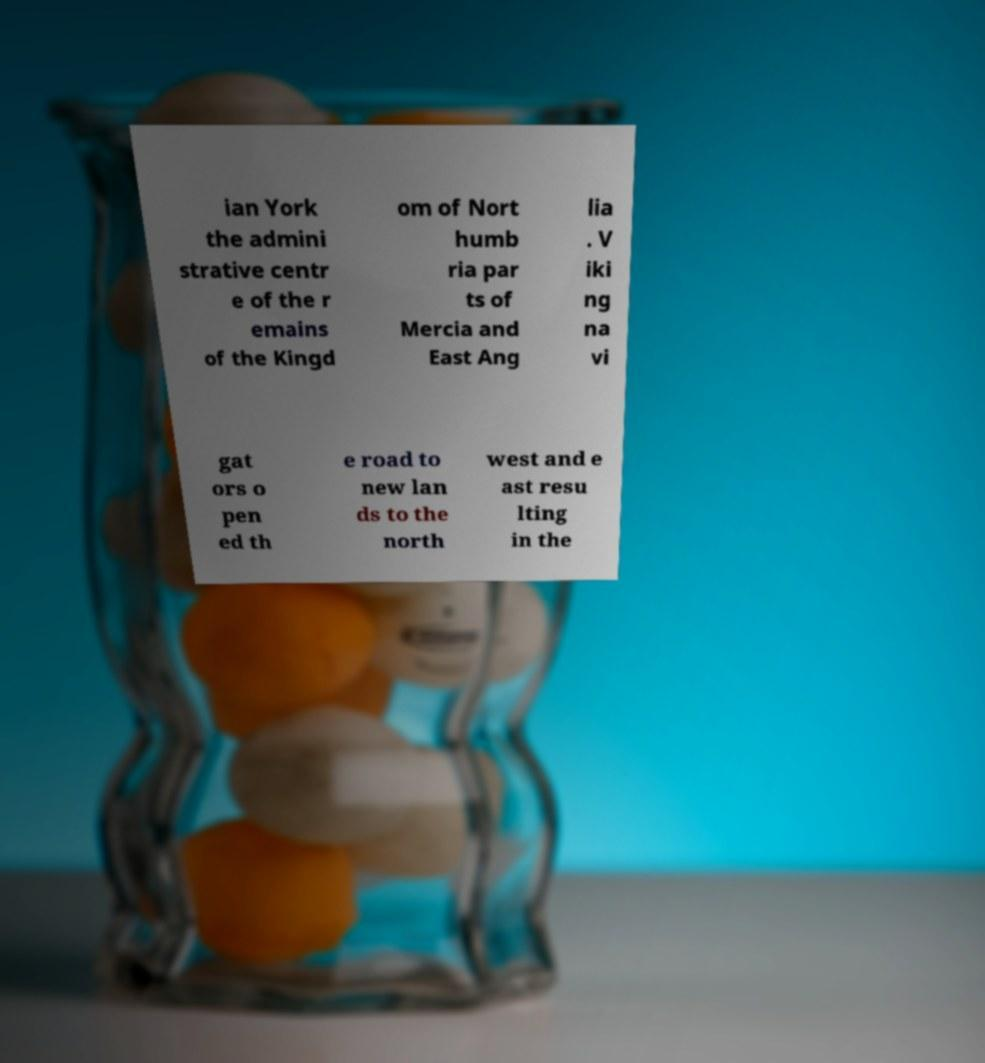Could you assist in decoding the text presented in this image and type it out clearly? ian York the admini strative centr e of the r emains of the Kingd om of Nort humb ria par ts of Mercia and East Ang lia . V iki ng na vi gat ors o pen ed th e road to new lan ds to the north west and e ast resu lting in the 